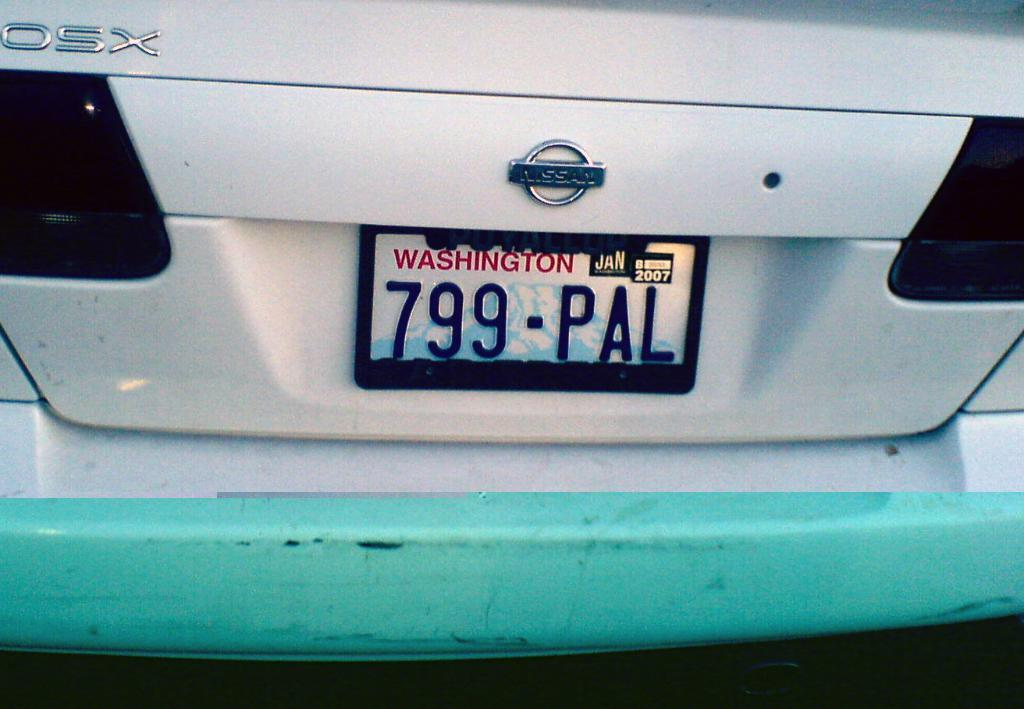<image>
Present a compact description of the photo's key features. a license plate that has 799 on the back 